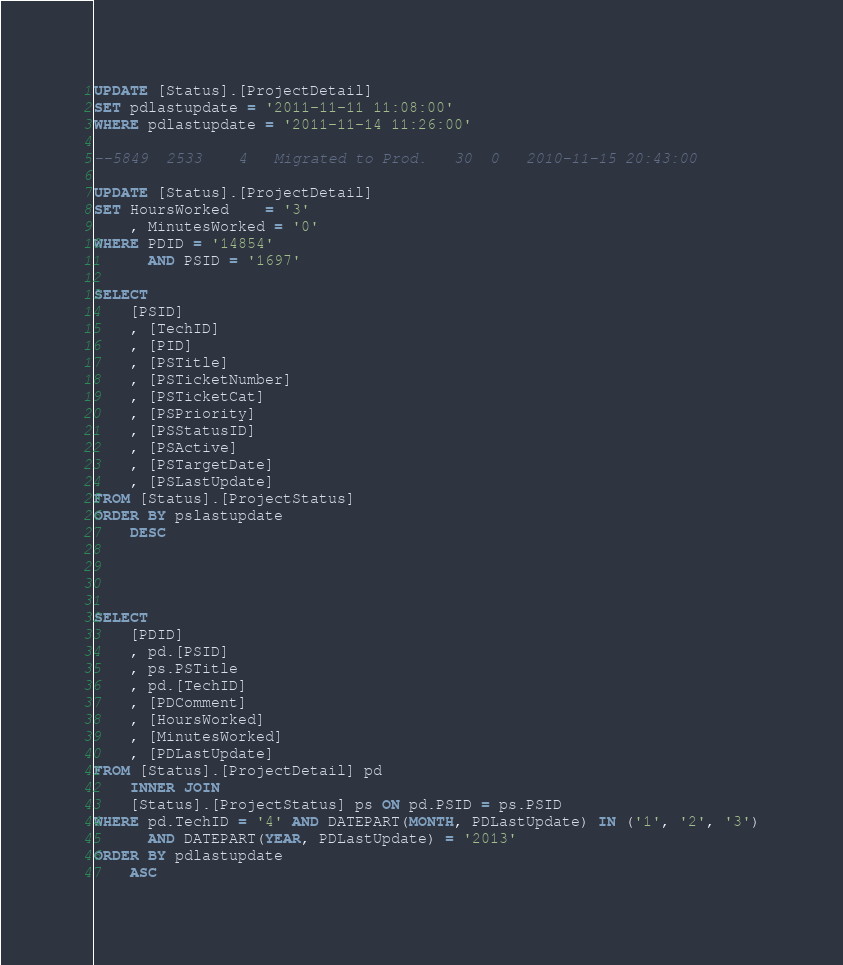Convert code to text. <code><loc_0><loc_0><loc_500><loc_500><_SQL_>UPDATE [Status].[ProjectDetail]
SET pdlastupdate = '2011-11-11 11:08:00'
WHERE pdlastupdate = '2011-11-14 11:26:00'

--5849  2533    4   Migrated to Prod.   30  0   2010-11-15 20:43:00

UPDATE [Status].[ProjectDetail]
SET HoursWorked    = '3'
    , MinutesWorked = '0'
WHERE PDID = '14854'
      AND PSID = '1697'

SELECT
    [PSID]
    , [TechID]
    , [PID]
    , [PSTitle]
    , [PSTicketNumber]
    , [PSTicketCat]
    , [PSPriority]
    , [PSStatusID]
    , [PSActive]
    , [PSTargetDate]
    , [PSLastUpdate]
FROM [Status].[ProjectStatus]
ORDER BY pslastupdate
    DESC




SELECT
    [PDID]
    , pd.[PSID]
    , ps.PSTitle
    , pd.[TechID]
    , [PDComment]
    , [HoursWorked]
    , [MinutesWorked]
    , [PDLastUpdate]
FROM [Status].[ProjectDetail] pd
    INNER JOIN
    [Status].[ProjectStatus] ps ON pd.PSID = ps.PSID
WHERE pd.TechID = '4' AND DATEPART(MONTH, PDLastUpdate) IN ('1', '2', '3')
      AND DATEPART(YEAR, PDLastUpdate) = '2013'
ORDER BY pdlastupdate
    ASC</code> 